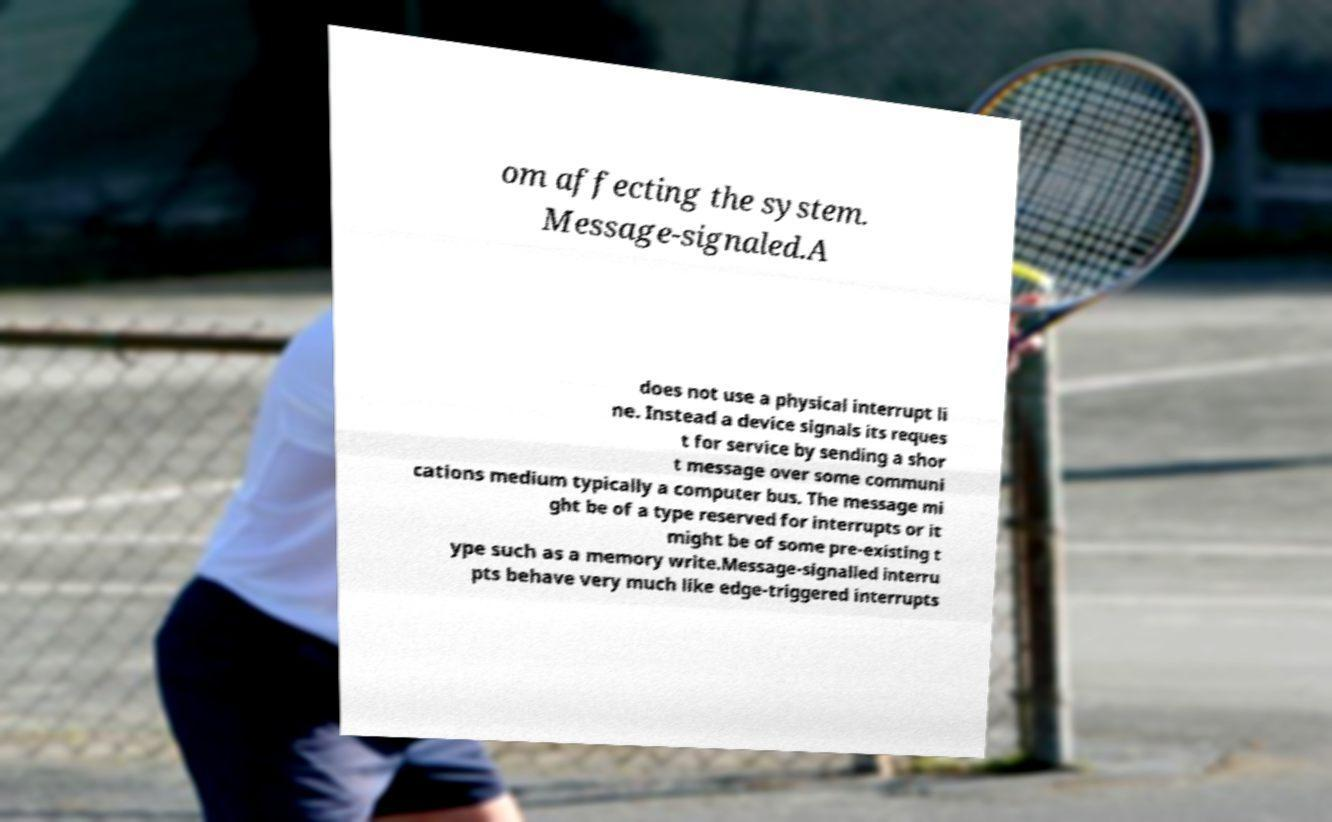What messages or text are displayed in this image? I need them in a readable, typed format. om affecting the system. Message-signaled.A does not use a physical interrupt li ne. Instead a device signals its reques t for service by sending a shor t message over some communi cations medium typically a computer bus. The message mi ght be of a type reserved for interrupts or it might be of some pre-existing t ype such as a memory write.Message-signalled interru pts behave very much like edge-triggered interrupts 